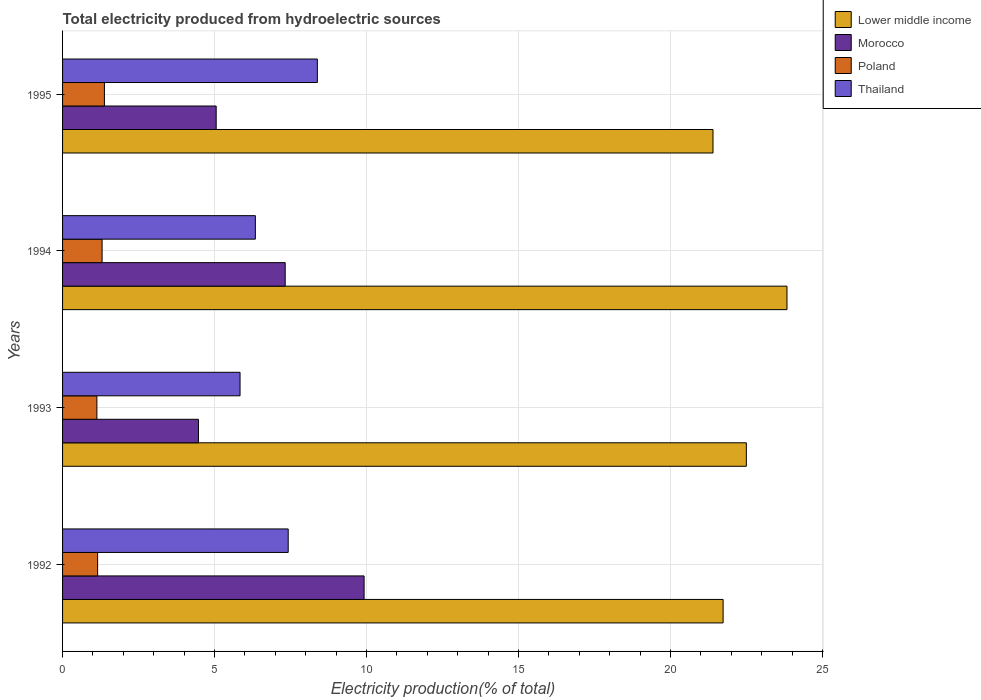How many different coloured bars are there?
Make the answer very short. 4. How many groups of bars are there?
Your response must be concise. 4. Are the number of bars per tick equal to the number of legend labels?
Provide a succinct answer. Yes. Are the number of bars on each tick of the Y-axis equal?
Provide a succinct answer. Yes. How many bars are there on the 3rd tick from the top?
Provide a succinct answer. 4. In how many cases, is the number of bars for a given year not equal to the number of legend labels?
Make the answer very short. 0. What is the total electricity produced in Thailand in 1994?
Keep it short and to the point. 6.34. Across all years, what is the maximum total electricity produced in Lower middle income?
Your response must be concise. 23.83. Across all years, what is the minimum total electricity produced in Lower middle income?
Offer a terse response. 21.4. In which year was the total electricity produced in Morocco minimum?
Provide a short and direct response. 1993. What is the total total electricity produced in Thailand in the graph?
Your response must be concise. 27.98. What is the difference between the total electricity produced in Lower middle income in 1992 and that in 1994?
Provide a succinct answer. -2.1. What is the difference between the total electricity produced in Lower middle income in 1994 and the total electricity produced in Poland in 1995?
Offer a terse response. 22.45. What is the average total electricity produced in Lower middle income per year?
Provide a succinct answer. 22.36. In the year 1993, what is the difference between the total electricity produced in Morocco and total electricity produced in Lower middle income?
Provide a short and direct response. -18.02. In how many years, is the total electricity produced in Lower middle income greater than 13 %?
Provide a succinct answer. 4. What is the ratio of the total electricity produced in Poland in 1992 to that in 1995?
Your answer should be compact. 0.84. What is the difference between the highest and the second highest total electricity produced in Poland?
Your response must be concise. 0.08. What is the difference between the highest and the lowest total electricity produced in Morocco?
Your response must be concise. 5.45. In how many years, is the total electricity produced in Thailand greater than the average total electricity produced in Thailand taken over all years?
Provide a succinct answer. 2. Is the sum of the total electricity produced in Morocco in 1992 and 1995 greater than the maximum total electricity produced in Poland across all years?
Give a very brief answer. Yes. Is it the case that in every year, the sum of the total electricity produced in Lower middle income and total electricity produced in Thailand is greater than the sum of total electricity produced in Poland and total electricity produced in Morocco?
Give a very brief answer. No. What does the 4th bar from the top in 1994 represents?
Make the answer very short. Lower middle income. What does the 4th bar from the bottom in 1994 represents?
Give a very brief answer. Thailand. How many bars are there?
Ensure brevity in your answer.  16. Are all the bars in the graph horizontal?
Your response must be concise. Yes. How many years are there in the graph?
Offer a terse response. 4. Does the graph contain grids?
Your answer should be compact. Yes. How many legend labels are there?
Keep it short and to the point. 4. What is the title of the graph?
Keep it short and to the point. Total electricity produced from hydroelectric sources. Does "East Asia (developing only)" appear as one of the legend labels in the graph?
Give a very brief answer. No. What is the Electricity production(% of total) in Lower middle income in 1992?
Your response must be concise. 21.73. What is the Electricity production(% of total) of Morocco in 1992?
Make the answer very short. 9.92. What is the Electricity production(% of total) in Poland in 1992?
Make the answer very short. 1.15. What is the Electricity production(% of total) in Thailand in 1992?
Provide a succinct answer. 7.42. What is the Electricity production(% of total) of Lower middle income in 1993?
Your response must be concise. 22.49. What is the Electricity production(% of total) in Morocco in 1993?
Provide a succinct answer. 4.47. What is the Electricity production(% of total) in Poland in 1993?
Provide a succinct answer. 1.13. What is the Electricity production(% of total) in Thailand in 1993?
Your answer should be compact. 5.84. What is the Electricity production(% of total) of Lower middle income in 1994?
Ensure brevity in your answer.  23.83. What is the Electricity production(% of total) in Morocco in 1994?
Your response must be concise. 7.32. What is the Electricity production(% of total) of Poland in 1994?
Give a very brief answer. 1.3. What is the Electricity production(% of total) of Thailand in 1994?
Offer a terse response. 6.34. What is the Electricity production(% of total) of Lower middle income in 1995?
Provide a short and direct response. 21.4. What is the Electricity production(% of total) in Morocco in 1995?
Make the answer very short. 5.05. What is the Electricity production(% of total) of Poland in 1995?
Your answer should be compact. 1.38. What is the Electricity production(% of total) of Thailand in 1995?
Your answer should be compact. 8.38. Across all years, what is the maximum Electricity production(% of total) in Lower middle income?
Provide a short and direct response. 23.83. Across all years, what is the maximum Electricity production(% of total) of Morocco?
Give a very brief answer. 9.92. Across all years, what is the maximum Electricity production(% of total) of Poland?
Make the answer very short. 1.38. Across all years, what is the maximum Electricity production(% of total) in Thailand?
Provide a succinct answer. 8.38. Across all years, what is the minimum Electricity production(% of total) of Lower middle income?
Offer a terse response. 21.4. Across all years, what is the minimum Electricity production(% of total) in Morocco?
Provide a succinct answer. 4.47. Across all years, what is the minimum Electricity production(% of total) in Poland?
Give a very brief answer. 1.13. Across all years, what is the minimum Electricity production(% of total) of Thailand?
Keep it short and to the point. 5.84. What is the total Electricity production(% of total) in Lower middle income in the graph?
Offer a terse response. 89.45. What is the total Electricity production(% of total) in Morocco in the graph?
Provide a succinct answer. 26.77. What is the total Electricity production(% of total) in Poland in the graph?
Provide a short and direct response. 4.96. What is the total Electricity production(% of total) in Thailand in the graph?
Ensure brevity in your answer.  27.98. What is the difference between the Electricity production(% of total) of Lower middle income in 1992 and that in 1993?
Provide a succinct answer. -0.76. What is the difference between the Electricity production(% of total) in Morocco in 1992 and that in 1993?
Give a very brief answer. 5.45. What is the difference between the Electricity production(% of total) in Poland in 1992 and that in 1993?
Your answer should be very brief. 0.02. What is the difference between the Electricity production(% of total) in Thailand in 1992 and that in 1993?
Offer a terse response. 1.58. What is the difference between the Electricity production(% of total) in Lower middle income in 1992 and that in 1994?
Offer a terse response. -2.1. What is the difference between the Electricity production(% of total) of Morocco in 1992 and that in 1994?
Offer a terse response. 2.6. What is the difference between the Electricity production(% of total) of Poland in 1992 and that in 1994?
Your answer should be very brief. -0.15. What is the difference between the Electricity production(% of total) of Thailand in 1992 and that in 1994?
Give a very brief answer. 1.08. What is the difference between the Electricity production(% of total) in Lower middle income in 1992 and that in 1995?
Ensure brevity in your answer.  0.33. What is the difference between the Electricity production(% of total) of Morocco in 1992 and that in 1995?
Keep it short and to the point. 4.87. What is the difference between the Electricity production(% of total) of Poland in 1992 and that in 1995?
Offer a terse response. -0.22. What is the difference between the Electricity production(% of total) in Thailand in 1992 and that in 1995?
Your response must be concise. -0.96. What is the difference between the Electricity production(% of total) in Lower middle income in 1993 and that in 1994?
Provide a short and direct response. -1.34. What is the difference between the Electricity production(% of total) of Morocco in 1993 and that in 1994?
Provide a short and direct response. -2.85. What is the difference between the Electricity production(% of total) of Poland in 1993 and that in 1994?
Keep it short and to the point. -0.17. What is the difference between the Electricity production(% of total) in Thailand in 1993 and that in 1994?
Offer a very short reply. -0.5. What is the difference between the Electricity production(% of total) in Lower middle income in 1993 and that in 1995?
Offer a terse response. 1.1. What is the difference between the Electricity production(% of total) of Morocco in 1993 and that in 1995?
Give a very brief answer. -0.58. What is the difference between the Electricity production(% of total) of Poland in 1993 and that in 1995?
Make the answer very short. -0.25. What is the difference between the Electricity production(% of total) of Thailand in 1993 and that in 1995?
Your answer should be compact. -2.54. What is the difference between the Electricity production(% of total) of Lower middle income in 1994 and that in 1995?
Ensure brevity in your answer.  2.43. What is the difference between the Electricity production(% of total) in Morocco in 1994 and that in 1995?
Provide a succinct answer. 2.27. What is the difference between the Electricity production(% of total) in Poland in 1994 and that in 1995?
Offer a terse response. -0.08. What is the difference between the Electricity production(% of total) in Thailand in 1994 and that in 1995?
Keep it short and to the point. -2.04. What is the difference between the Electricity production(% of total) in Lower middle income in 1992 and the Electricity production(% of total) in Morocco in 1993?
Give a very brief answer. 17.26. What is the difference between the Electricity production(% of total) of Lower middle income in 1992 and the Electricity production(% of total) of Poland in 1993?
Give a very brief answer. 20.6. What is the difference between the Electricity production(% of total) of Lower middle income in 1992 and the Electricity production(% of total) of Thailand in 1993?
Provide a short and direct response. 15.89. What is the difference between the Electricity production(% of total) in Morocco in 1992 and the Electricity production(% of total) in Poland in 1993?
Offer a terse response. 8.79. What is the difference between the Electricity production(% of total) in Morocco in 1992 and the Electricity production(% of total) in Thailand in 1993?
Keep it short and to the point. 4.08. What is the difference between the Electricity production(% of total) of Poland in 1992 and the Electricity production(% of total) of Thailand in 1993?
Offer a terse response. -4.69. What is the difference between the Electricity production(% of total) in Lower middle income in 1992 and the Electricity production(% of total) in Morocco in 1994?
Keep it short and to the point. 14.41. What is the difference between the Electricity production(% of total) of Lower middle income in 1992 and the Electricity production(% of total) of Poland in 1994?
Ensure brevity in your answer.  20.43. What is the difference between the Electricity production(% of total) in Lower middle income in 1992 and the Electricity production(% of total) in Thailand in 1994?
Offer a very short reply. 15.39. What is the difference between the Electricity production(% of total) of Morocco in 1992 and the Electricity production(% of total) of Poland in 1994?
Offer a terse response. 8.62. What is the difference between the Electricity production(% of total) of Morocco in 1992 and the Electricity production(% of total) of Thailand in 1994?
Offer a very short reply. 3.58. What is the difference between the Electricity production(% of total) in Poland in 1992 and the Electricity production(% of total) in Thailand in 1994?
Offer a terse response. -5.19. What is the difference between the Electricity production(% of total) in Lower middle income in 1992 and the Electricity production(% of total) in Morocco in 1995?
Give a very brief answer. 16.68. What is the difference between the Electricity production(% of total) in Lower middle income in 1992 and the Electricity production(% of total) in Poland in 1995?
Provide a short and direct response. 20.35. What is the difference between the Electricity production(% of total) in Lower middle income in 1992 and the Electricity production(% of total) in Thailand in 1995?
Keep it short and to the point. 13.35. What is the difference between the Electricity production(% of total) of Morocco in 1992 and the Electricity production(% of total) of Poland in 1995?
Make the answer very short. 8.54. What is the difference between the Electricity production(% of total) in Morocco in 1992 and the Electricity production(% of total) in Thailand in 1995?
Give a very brief answer. 1.54. What is the difference between the Electricity production(% of total) of Poland in 1992 and the Electricity production(% of total) of Thailand in 1995?
Make the answer very short. -7.23. What is the difference between the Electricity production(% of total) of Lower middle income in 1993 and the Electricity production(% of total) of Morocco in 1994?
Give a very brief answer. 15.17. What is the difference between the Electricity production(% of total) of Lower middle income in 1993 and the Electricity production(% of total) of Poland in 1994?
Give a very brief answer. 21.19. What is the difference between the Electricity production(% of total) of Lower middle income in 1993 and the Electricity production(% of total) of Thailand in 1994?
Make the answer very short. 16.15. What is the difference between the Electricity production(% of total) of Morocco in 1993 and the Electricity production(% of total) of Poland in 1994?
Offer a terse response. 3.17. What is the difference between the Electricity production(% of total) of Morocco in 1993 and the Electricity production(% of total) of Thailand in 1994?
Ensure brevity in your answer.  -1.87. What is the difference between the Electricity production(% of total) in Poland in 1993 and the Electricity production(% of total) in Thailand in 1994?
Offer a terse response. -5.21. What is the difference between the Electricity production(% of total) of Lower middle income in 1993 and the Electricity production(% of total) of Morocco in 1995?
Make the answer very short. 17.44. What is the difference between the Electricity production(% of total) of Lower middle income in 1993 and the Electricity production(% of total) of Poland in 1995?
Your response must be concise. 21.12. What is the difference between the Electricity production(% of total) in Lower middle income in 1993 and the Electricity production(% of total) in Thailand in 1995?
Your answer should be very brief. 14.11. What is the difference between the Electricity production(% of total) in Morocco in 1993 and the Electricity production(% of total) in Poland in 1995?
Offer a terse response. 3.09. What is the difference between the Electricity production(% of total) of Morocco in 1993 and the Electricity production(% of total) of Thailand in 1995?
Offer a terse response. -3.91. What is the difference between the Electricity production(% of total) in Poland in 1993 and the Electricity production(% of total) in Thailand in 1995?
Your response must be concise. -7.25. What is the difference between the Electricity production(% of total) in Lower middle income in 1994 and the Electricity production(% of total) in Morocco in 1995?
Make the answer very short. 18.78. What is the difference between the Electricity production(% of total) of Lower middle income in 1994 and the Electricity production(% of total) of Poland in 1995?
Provide a succinct answer. 22.45. What is the difference between the Electricity production(% of total) in Lower middle income in 1994 and the Electricity production(% of total) in Thailand in 1995?
Keep it short and to the point. 15.45. What is the difference between the Electricity production(% of total) of Morocco in 1994 and the Electricity production(% of total) of Poland in 1995?
Offer a terse response. 5.95. What is the difference between the Electricity production(% of total) in Morocco in 1994 and the Electricity production(% of total) in Thailand in 1995?
Make the answer very short. -1.06. What is the difference between the Electricity production(% of total) in Poland in 1994 and the Electricity production(% of total) in Thailand in 1995?
Offer a terse response. -7.08. What is the average Electricity production(% of total) in Lower middle income per year?
Keep it short and to the point. 22.36. What is the average Electricity production(% of total) in Morocco per year?
Keep it short and to the point. 6.69. What is the average Electricity production(% of total) of Poland per year?
Make the answer very short. 1.24. What is the average Electricity production(% of total) in Thailand per year?
Make the answer very short. 7. In the year 1992, what is the difference between the Electricity production(% of total) in Lower middle income and Electricity production(% of total) in Morocco?
Your answer should be very brief. 11.81. In the year 1992, what is the difference between the Electricity production(% of total) of Lower middle income and Electricity production(% of total) of Poland?
Keep it short and to the point. 20.58. In the year 1992, what is the difference between the Electricity production(% of total) of Lower middle income and Electricity production(% of total) of Thailand?
Your answer should be compact. 14.31. In the year 1992, what is the difference between the Electricity production(% of total) in Morocco and Electricity production(% of total) in Poland?
Give a very brief answer. 8.77. In the year 1992, what is the difference between the Electricity production(% of total) of Morocco and Electricity production(% of total) of Thailand?
Provide a short and direct response. 2.5. In the year 1992, what is the difference between the Electricity production(% of total) in Poland and Electricity production(% of total) in Thailand?
Offer a terse response. -6.27. In the year 1993, what is the difference between the Electricity production(% of total) of Lower middle income and Electricity production(% of total) of Morocco?
Your answer should be compact. 18.02. In the year 1993, what is the difference between the Electricity production(% of total) in Lower middle income and Electricity production(% of total) in Poland?
Provide a succinct answer. 21.36. In the year 1993, what is the difference between the Electricity production(% of total) of Lower middle income and Electricity production(% of total) of Thailand?
Your answer should be very brief. 16.65. In the year 1993, what is the difference between the Electricity production(% of total) in Morocco and Electricity production(% of total) in Poland?
Your response must be concise. 3.34. In the year 1993, what is the difference between the Electricity production(% of total) in Morocco and Electricity production(% of total) in Thailand?
Your answer should be very brief. -1.37. In the year 1993, what is the difference between the Electricity production(% of total) in Poland and Electricity production(% of total) in Thailand?
Your response must be concise. -4.71. In the year 1994, what is the difference between the Electricity production(% of total) of Lower middle income and Electricity production(% of total) of Morocco?
Offer a terse response. 16.51. In the year 1994, what is the difference between the Electricity production(% of total) of Lower middle income and Electricity production(% of total) of Poland?
Make the answer very short. 22.53. In the year 1994, what is the difference between the Electricity production(% of total) in Lower middle income and Electricity production(% of total) in Thailand?
Give a very brief answer. 17.49. In the year 1994, what is the difference between the Electricity production(% of total) of Morocco and Electricity production(% of total) of Poland?
Provide a short and direct response. 6.02. In the year 1994, what is the difference between the Electricity production(% of total) in Morocco and Electricity production(% of total) in Thailand?
Give a very brief answer. 0.98. In the year 1994, what is the difference between the Electricity production(% of total) in Poland and Electricity production(% of total) in Thailand?
Your answer should be compact. -5.04. In the year 1995, what is the difference between the Electricity production(% of total) in Lower middle income and Electricity production(% of total) in Morocco?
Give a very brief answer. 16.34. In the year 1995, what is the difference between the Electricity production(% of total) of Lower middle income and Electricity production(% of total) of Poland?
Offer a very short reply. 20.02. In the year 1995, what is the difference between the Electricity production(% of total) in Lower middle income and Electricity production(% of total) in Thailand?
Offer a terse response. 13.02. In the year 1995, what is the difference between the Electricity production(% of total) in Morocco and Electricity production(% of total) in Poland?
Your response must be concise. 3.68. In the year 1995, what is the difference between the Electricity production(% of total) of Morocco and Electricity production(% of total) of Thailand?
Give a very brief answer. -3.33. In the year 1995, what is the difference between the Electricity production(% of total) in Poland and Electricity production(% of total) in Thailand?
Offer a very short reply. -7. What is the ratio of the Electricity production(% of total) in Morocco in 1992 to that in 1993?
Your answer should be compact. 2.22. What is the ratio of the Electricity production(% of total) in Poland in 1992 to that in 1993?
Offer a terse response. 1.02. What is the ratio of the Electricity production(% of total) in Thailand in 1992 to that in 1993?
Make the answer very short. 1.27. What is the ratio of the Electricity production(% of total) of Lower middle income in 1992 to that in 1994?
Your answer should be compact. 0.91. What is the ratio of the Electricity production(% of total) of Morocco in 1992 to that in 1994?
Offer a very short reply. 1.35. What is the ratio of the Electricity production(% of total) of Poland in 1992 to that in 1994?
Offer a terse response. 0.89. What is the ratio of the Electricity production(% of total) of Thailand in 1992 to that in 1994?
Ensure brevity in your answer.  1.17. What is the ratio of the Electricity production(% of total) in Lower middle income in 1992 to that in 1995?
Offer a very short reply. 1.02. What is the ratio of the Electricity production(% of total) in Morocco in 1992 to that in 1995?
Provide a short and direct response. 1.96. What is the ratio of the Electricity production(% of total) in Poland in 1992 to that in 1995?
Provide a succinct answer. 0.84. What is the ratio of the Electricity production(% of total) in Thailand in 1992 to that in 1995?
Your answer should be very brief. 0.89. What is the ratio of the Electricity production(% of total) in Lower middle income in 1993 to that in 1994?
Give a very brief answer. 0.94. What is the ratio of the Electricity production(% of total) in Morocco in 1993 to that in 1994?
Make the answer very short. 0.61. What is the ratio of the Electricity production(% of total) of Poland in 1993 to that in 1994?
Your answer should be very brief. 0.87. What is the ratio of the Electricity production(% of total) in Thailand in 1993 to that in 1994?
Offer a terse response. 0.92. What is the ratio of the Electricity production(% of total) in Lower middle income in 1993 to that in 1995?
Give a very brief answer. 1.05. What is the ratio of the Electricity production(% of total) in Morocco in 1993 to that in 1995?
Make the answer very short. 0.88. What is the ratio of the Electricity production(% of total) of Poland in 1993 to that in 1995?
Your response must be concise. 0.82. What is the ratio of the Electricity production(% of total) in Thailand in 1993 to that in 1995?
Make the answer very short. 0.7. What is the ratio of the Electricity production(% of total) of Lower middle income in 1994 to that in 1995?
Provide a succinct answer. 1.11. What is the ratio of the Electricity production(% of total) of Morocco in 1994 to that in 1995?
Keep it short and to the point. 1.45. What is the ratio of the Electricity production(% of total) in Poland in 1994 to that in 1995?
Provide a short and direct response. 0.94. What is the ratio of the Electricity production(% of total) in Thailand in 1994 to that in 1995?
Offer a very short reply. 0.76. What is the difference between the highest and the second highest Electricity production(% of total) in Lower middle income?
Offer a terse response. 1.34. What is the difference between the highest and the second highest Electricity production(% of total) in Morocco?
Your answer should be compact. 2.6. What is the difference between the highest and the second highest Electricity production(% of total) of Poland?
Your response must be concise. 0.08. What is the difference between the highest and the second highest Electricity production(% of total) of Thailand?
Your answer should be very brief. 0.96. What is the difference between the highest and the lowest Electricity production(% of total) of Lower middle income?
Ensure brevity in your answer.  2.43. What is the difference between the highest and the lowest Electricity production(% of total) of Morocco?
Keep it short and to the point. 5.45. What is the difference between the highest and the lowest Electricity production(% of total) of Poland?
Offer a terse response. 0.25. What is the difference between the highest and the lowest Electricity production(% of total) of Thailand?
Give a very brief answer. 2.54. 